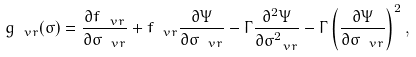Convert formula to latex. <formula><loc_0><loc_0><loc_500><loc_500>g _ { \ v r } ( \sigma ) = \frac { \partial f _ { \ v r } } { \partial \sigma _ { \ v r } } + f _ { \ v r } \frac { \partial \Psi } { \partial \sigma _ { \ v r } } - \Gamma \frac { \partial ^ { 2 } \Psi } { \partial \sigma _ { \ v r } ^ { 2 } } - \Gamma \left ( \frac { \partial \Psi } { \partial \sigma _ { \ v r } } \right ) ^ { 2 } ,</formula> 